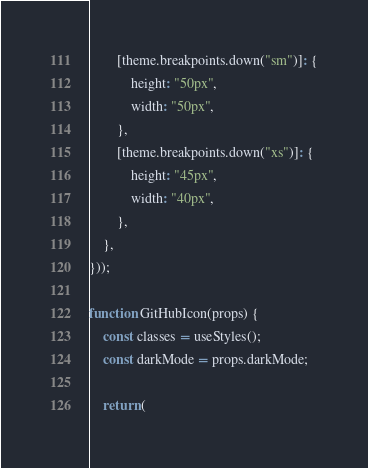<code> <loc_0><loc_0><loc_500><loc_500><_JavaScript_>		[theme.breakpoints.down("sm")]: {
			height: "50px",
			width: "50px",
		},
		[theme.breakpoints.down("xs")]: {
			height: "45px",
			width: "40px",
		},
	},
}));

function GitHubIcon(props) {
	const classes = useStyles();
	const darkMode = props.darkMode;

	return (</code> 